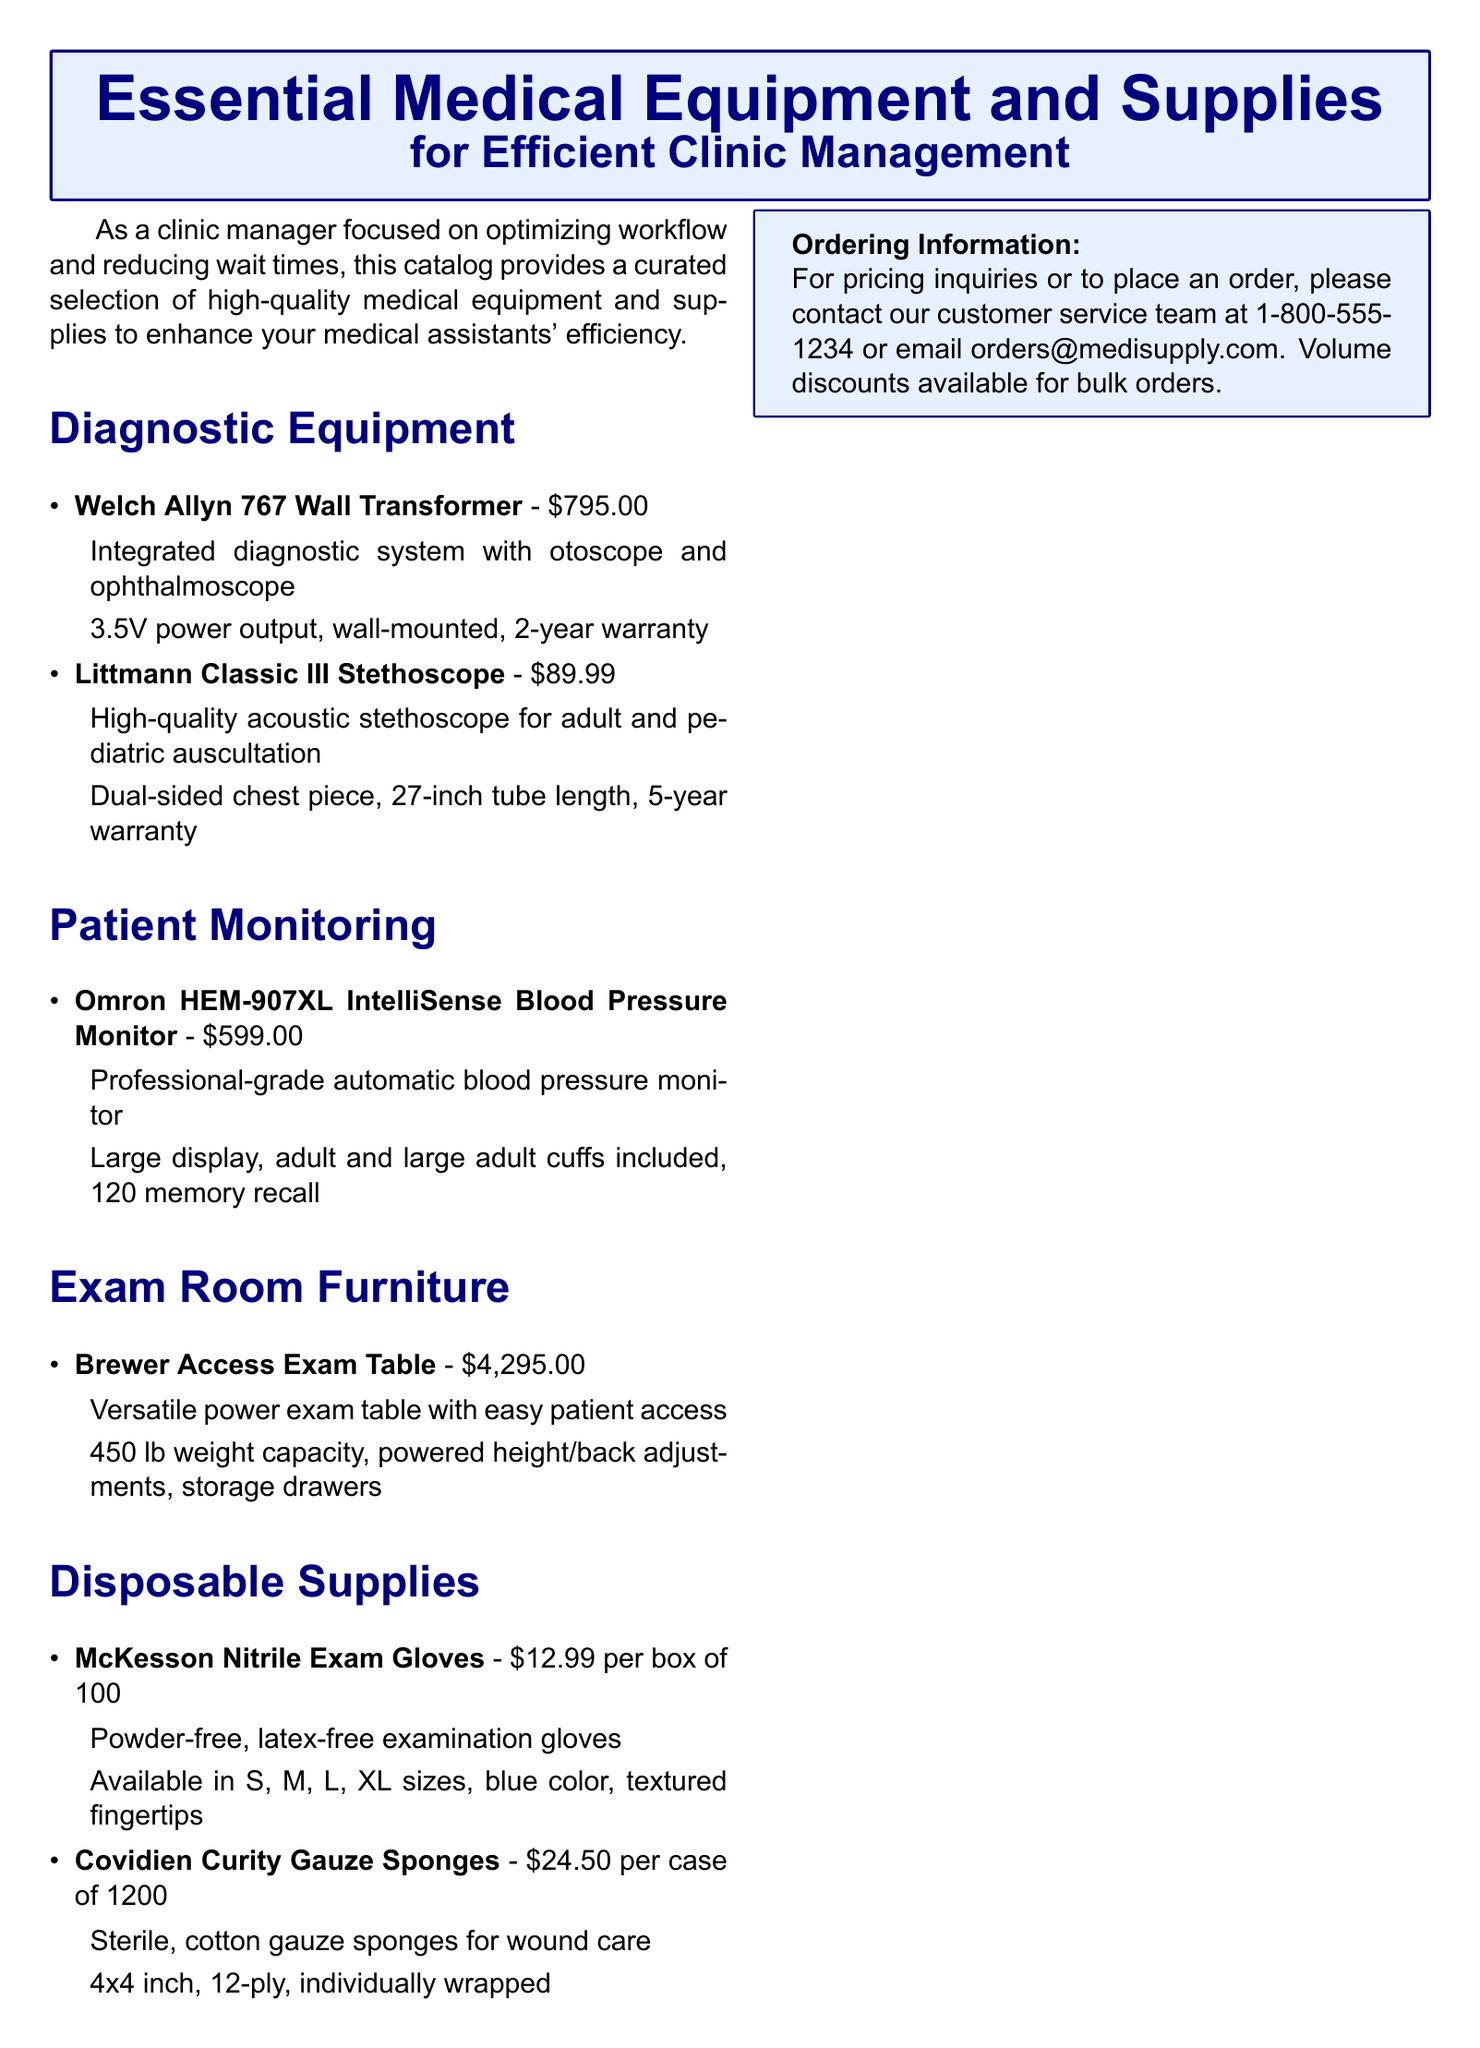What is the price of the Welch Allyn 767 Wall Transformer? The price is clearly stated next to the product name in the document, which is $795.00.
Answer: $795.00 How many memory recalls does the Omron HEM-907XL IntelliSense Blood Pressure Monitor have? This information is mentioned in the features of the blood pressure monitor, which states it has a 120 memory recall.
Answer: 120 What is the weight capacity of the Brewer Access Exam Table? The document specifies that it has a weight capacity, which is 450 lb.
Answer: 450 lb What type of gloves does McKesson offer in the catalog? The document describes McKesson Nitrile Gloves as powder-free and latex-free examination gloves.
Answer: Nitrile What year warranty does the Littmann Classic III Stethoscope have? The warranty information for the stethoscope is mentioned as a 5-year warranty.
Answer: 5-year Which product is described as having powered height/back adjustments? This feature belongs to the Brewer Access Exam Table, which offers powered adjustments for height and back.
Answer: Brewer Access Exam Table What size are the Covidien Curity Gauze Sponges? The document details that the size is 4x4 inch.
Answer: 4x4 inch Are volume discounts available for bulk orders? The catalog includes a note indicating that volume discounts are available for bulk orders, which suggests cost savings for purchasing in larger quantities.
Answer: Yes 